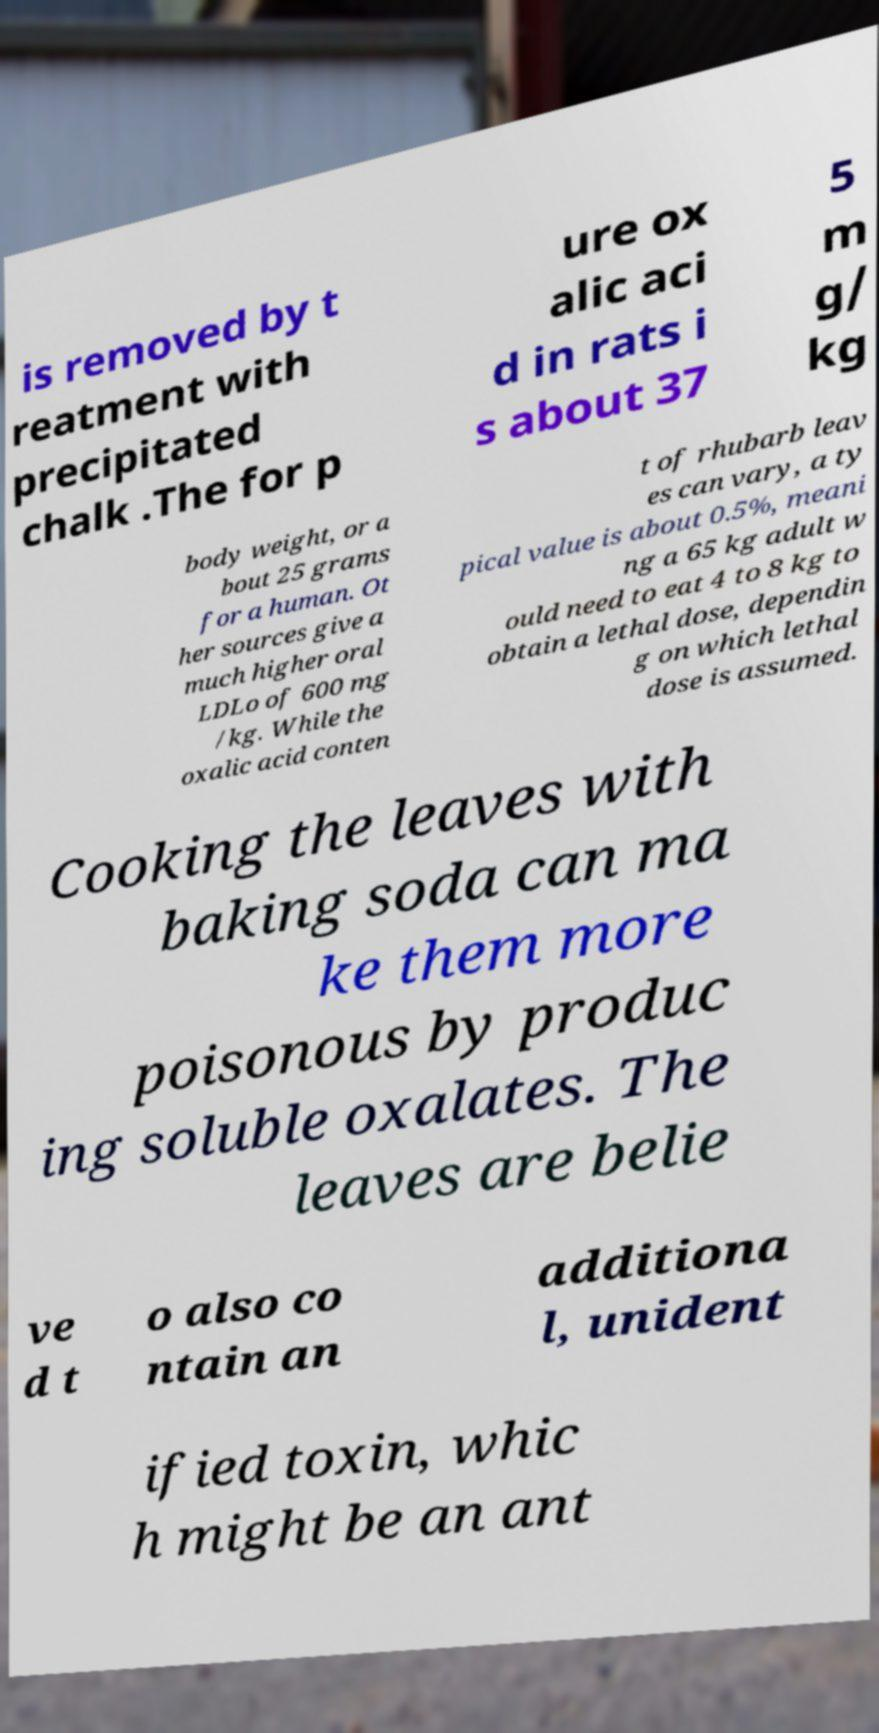What messages or text are displayed in this image? I need them in a readable, typed format. is removed by t reatment with precipitated chalk .The for p ure ox alic aci d in rats i s about 37 5 m g/ kg body weight, or a bout 25 grams for a human. Ot her sources give a much higher oral LDLo of 600 mg /kg. While the oxalic acid conten t of rhubarb leav es can vary, a ty pical value is about 0.5%, meani ng a 65 kg adult w ould need to eat 4 to 8 kg to obtain a lethal dose, dependin g on which lethal dose is assumed. Cooking the leaves with baking soda can ma ke them more poisonous by produc ing soluble oxalates. The leaves are belie ve d t o also co ntain an additiona l, unident ified toxin, whic h might be an ant 